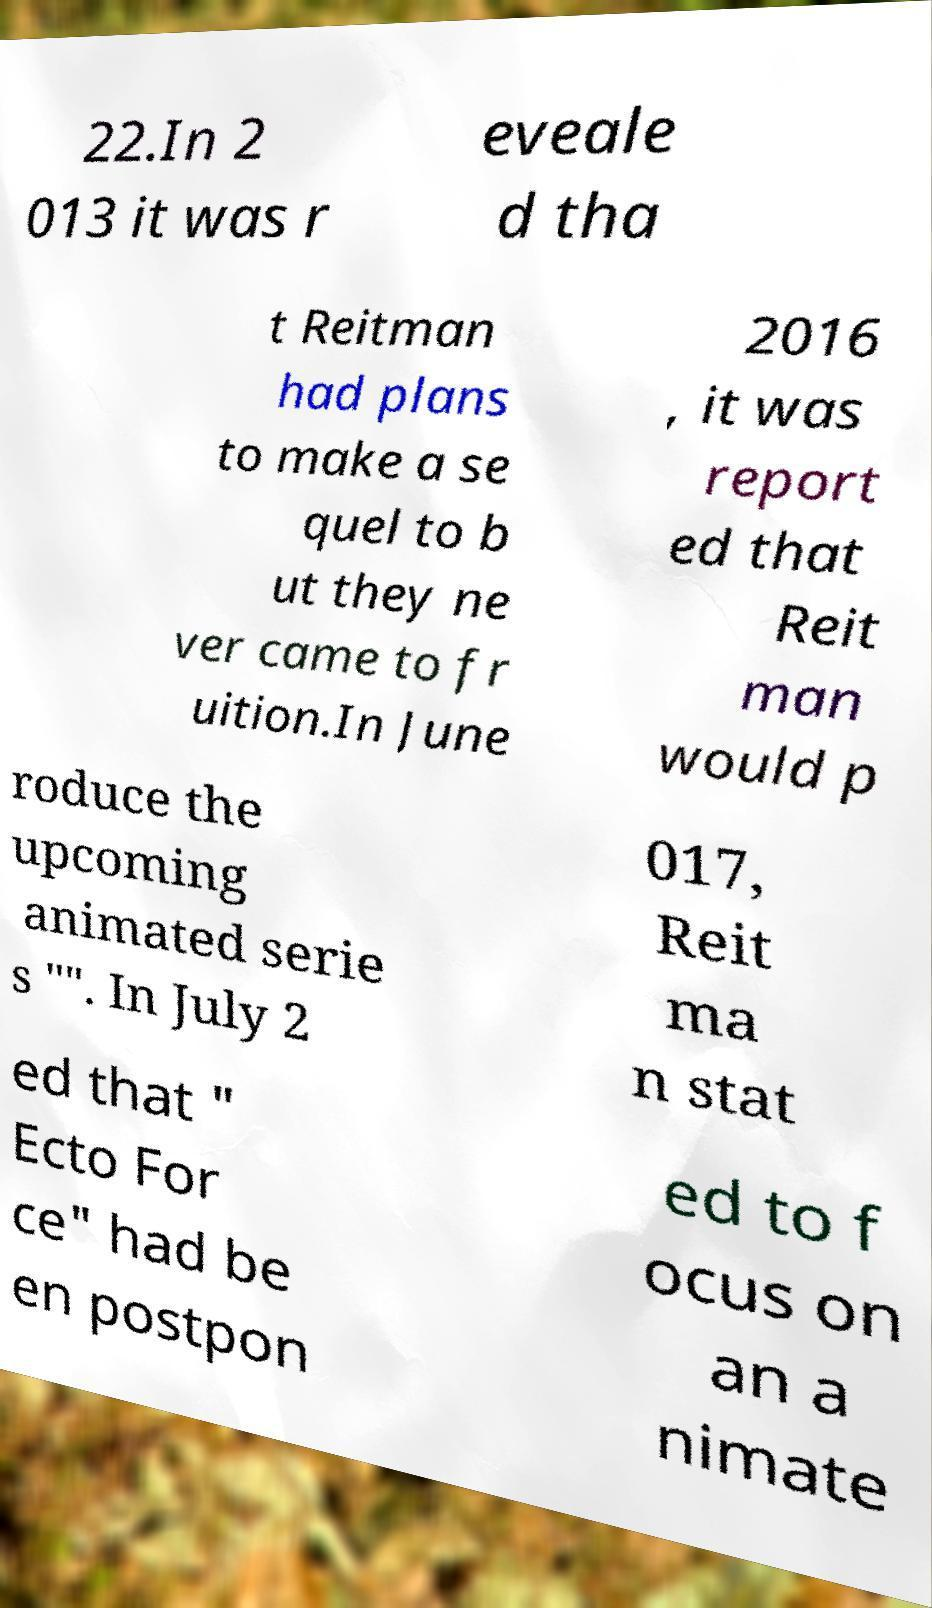There's text embedded in this image that I need extracted. Can you transcribe it verbatim? 22.In 2 013 it was r eveale d tha t Reitman had plans to make a se quel to b ut they ne ver came to fr uition.In June 2016 , it was report ed that Reit man would p roduce the upcoming animated serie s "". In July 2 017, Reit ma n stat ed that " Ecto For ce" had be en postpon ed to f ocus on an a nimate 